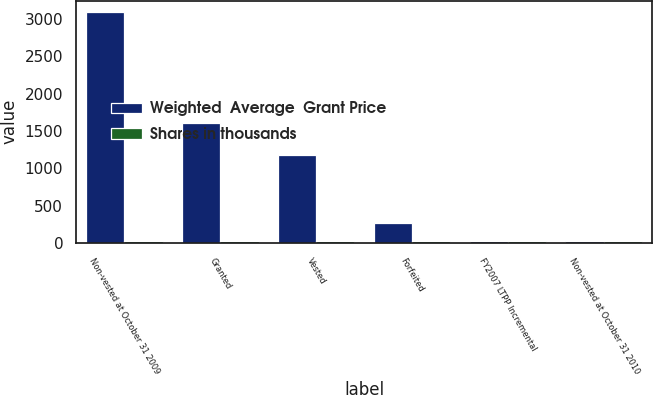Convert chart to OTSL. <chart><loc_0><loc_0><loc_500><loc_500><stacked_bar_chart><ecel><fcel>Non-vested at October 31 2009<fcel>Granted<fcel>Vested<fcel>Forfeited<fcel>FY2007 LTPP Incremental<fcel>Non-vested at October 31 2010<nl><fcel>Weighted  Average  Grant Price<fcel>3092<fcel>1612<fcel>1175<fcel>263<fcel>18<fcel>30<nl><fcel>Shares in thousands<fcel>30<fcel>30<fcel>31<fcel>29<fcel>29<fcel>29<nl></chart> 